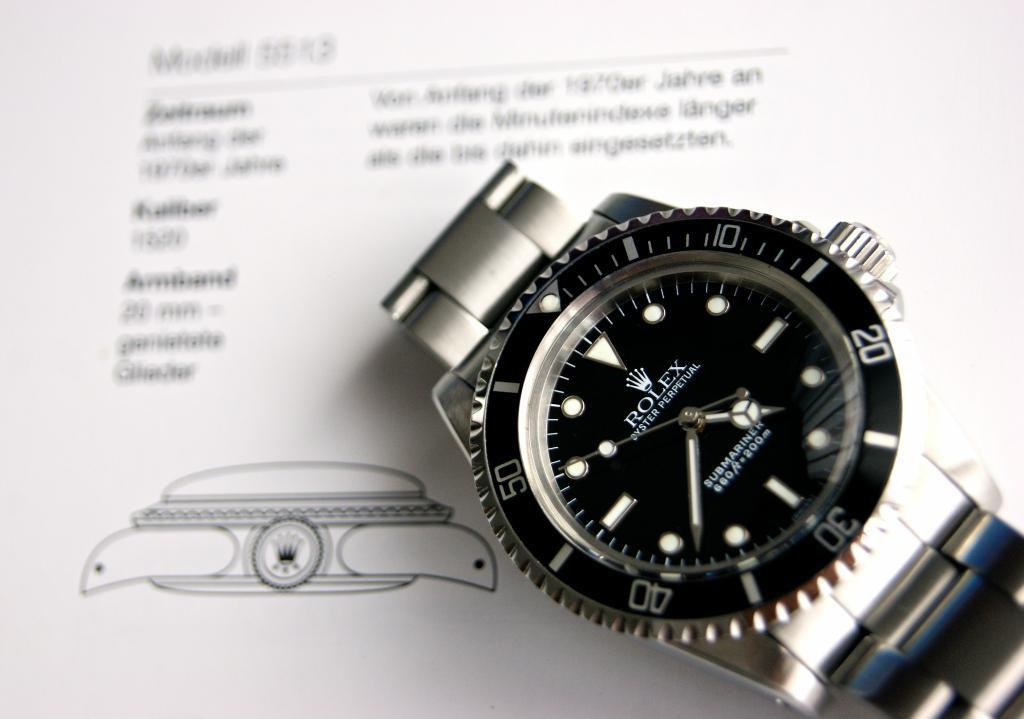Provide a one-sentence caption for the provided image. Black and silver wristwatch that says ROLEX on the face. 